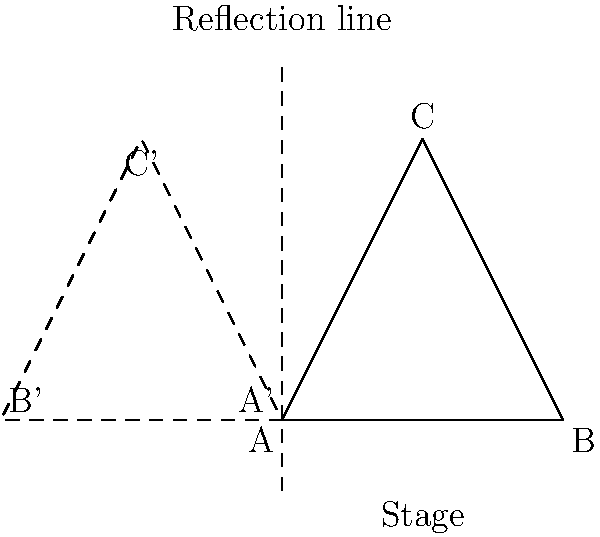In a stage performance, a triangular formation ABC represents the initial positioning of three performers. If this formation is reflected across the vertical line shown, how does this transformation affect the performers' positions relative to the audience, and what psychological impact might this have on performers experiencing stage fright? To answer this question, let's break it down step-by-step:

1. Initial formation: Triangle ABC represents the original position of the performers on stage.

2. Reflection: The triangle is reflected across the vertical line (y-axis).

3. Transformed formation: The reflected triangle A'B'C' shows the new positions of the performers.

4. Position changes:
   a) Left-right reversal: Performers on the left side of the stage (A) move to the right side (A'), and vice versa (B to B').
   b) Distance from the audience: The performer at point C moves farther from the audience (to C'), while A and B move closer.

5. Psychological impact on performers with stage fright:
   a) Spatial awareness: The change in positions may initially disorient performers, potentially increasing anxiety.
   b) Proximity to audience: Performers A and B moving closer to the audience might increase nervousness for those with stage fright.
   c) Familiarity: The overall change in formation might make performers feel less comfortable with their rehearsed positions.
   d) Focus shift: The transformation could serve as a distraction from anxiety, redirecting focus to the new positioning.

6. Potential strategies for managing stage fright in this scenario:
   a) Mental rehearsal: Visualizing the transformation beforehand to reduce surprise.
   b) Breathing techniques: Using controlled breathing to manage anxiety during position changes.
   c) Anchoring: Establishing new visual or physical anchors in the reflected positions.
   d) Reframing: Viewing the transformation as an opportunity for a fresh perspective rather than a challenge.
Answer: The reflection reverses left-right positioning and alters proximity to the audience, potentially increasing anxiety due to disorientation and closer audience interaction, but also offering an opportunity for distraction and reframing to manage stage fright. 